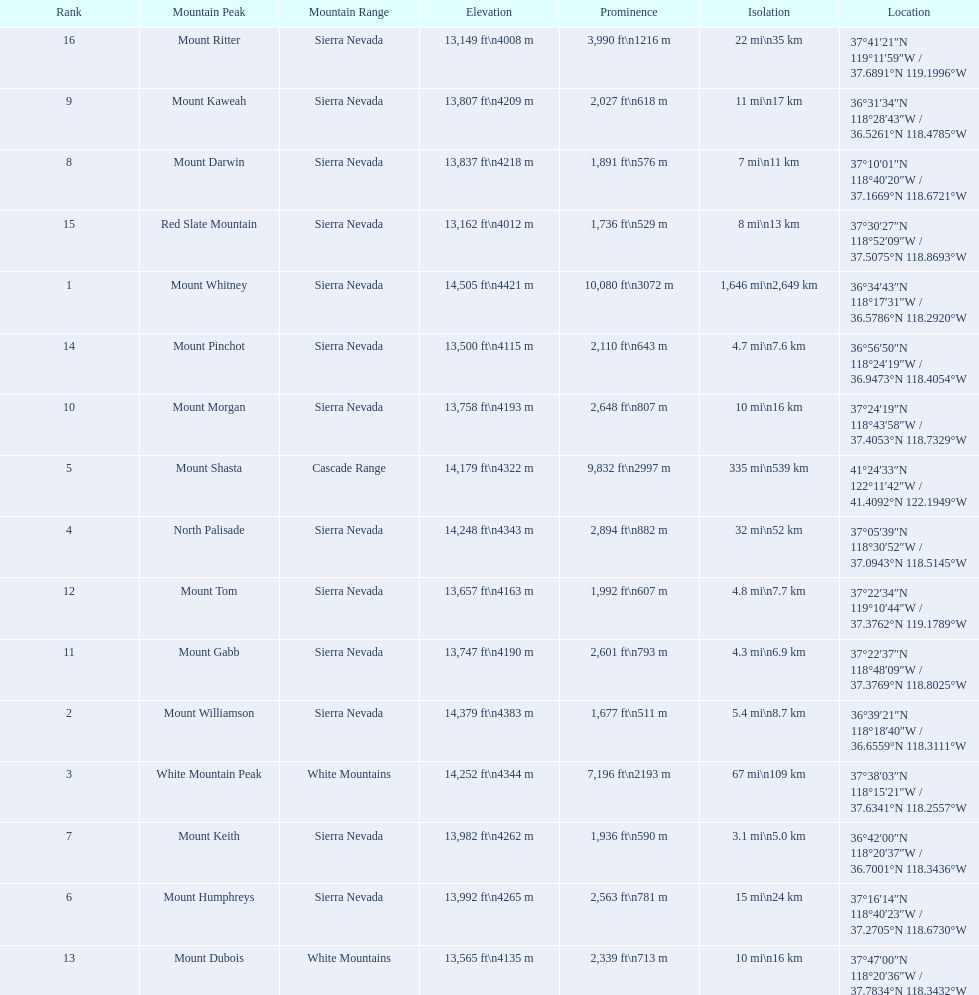Parse the full table. {'header': ['Rank', 'Mountain Peak', 'Mountain Range', 'Elevation', 'Prominence', 'Isolation', 'Location'], 'rows': [['16', 'Mount Ritter', 'Sierra Nevada', '13,149\xa0ft\\n4008\xa0m', '3,990\xa0ft\\n1216\xa0m', '22\xa0mi\\n35\xa0km', '37°41′21″N 119°11′59″W\ufeff / \ufeff37.6891°N 119.1996°W'], ['9', 'Mount Kaweah', 'Sierra Nevada', '13,807\xa0ft\\n4209\xa0m', '2,027\xa0ft\\n618\xa0m', '11\xa0mi\\n17\xa0km', '36°31′34″N 118°28′43″W\ufeff / \ufeff36.5261°N 118.4785°W'], ['8', 'Mount Darwin', 'Sierra Nevada', '13,837\xa0ft\\n4218\xa0m', '1,891\xa0ft\\n576\xa0m', '7\xa0mi\\n11\xa0km', '37°10′01″N 118°40′20″W\ufeff / \ufeff37.1669°N 118.6721°W'], ['15', 'Red Slate Mountain', 'Sierra Nevada', '13,162\xa0ft\\n4012\xa0m', '1,736\xa0ft\\n529\xa0m', '8\xa0mi\\n13\xa0km', '37°30′27″N 118°52′09″W\ufeff / \ufeff37.5075°N 118.8693°W'], ['1', 'Mount Whitney', 'Sierra Nevada', '14,505\xa0ft\\n4421\xa0m', '10,080\xa0ft\\n3072\xa0m', '1,646\xa0mi\\n2,649\xa0km', '36°34′43″N 118°17′31″W\ufeff / \ufeff36.5786°N 118.2920°W'], ['14', 'Mount Pinchot', 'Sierra Nevada', '13,500\xa0ft\\n4115\xa0m', '2,110\xa0ft\\n643\xa0m', '4.7\xa0mi\\n7.6\xa0km', '36°56′50″N 118°24′19″W\ufeff / \ufeff36.9473°N 118.4054°W'], ['10', 'Mount Morgan', 'Sierra Nevada', '13,758\xa0ft\\n4193\xa0m', '2,648\xa0ft\\n807\xa0m', '10\xa0mi\\n16\xa0km', '37°24′19″N 118°43′58″W\ufeff / \ufeff37.4053°N 118.7329°W'], ['5', 'Mount Shasta', 'Cascade Range', '14,179\xa0ft\\n4322\xa0m', '9,832\xa0ft\\n2997\xa0m', '335\xa0mi\\n539\xa0km', '41°24′33″N 122°11′42″W\ufeff / \ufeff41.4092°N 122.1949°W'], ['4', 'North Palisade', 'Sierra Nevada', '14,248\xa0ft\\n4343\xa0m', '2,894\xa0ft\\n882\xa0m', '32\xa0mi\\n52\xa0km', '37°05′39″N 118°30′52″W\ufeff / \ufeff37.0943°N 118.5145°W'], ['12', 'Mount Tom', 'Sierra Nevada', '13,657\xa0ft\\n4163\xa0m', '1,992\xa0ft\\n607\xa0m', '4.8\xa0mi\\n7.7\xa0km', '37°22′34″N 119°10′44″W\ufeff / \ufeff37.3762°N 119.1789°W'], ['11', 'Mount Gabb', 'Sierra Nevada', '13,747\xa0ft\\n4190\xa0m', '2,601\xa0ft\\n793\xa0m', '4.3\xa0mi\\n6.9\xa0km', '37°22′37″N 118°48′09″W\ufeff / \ufeff37.3769°N 118.8025°W'], ['2', 'Mount Williamson', 'Sierra Nevada', '14,379\xa0ft\\n4383\xa0m', '1,677\xa0ft\\n511\xa0m', '5.4\xa0mi\\n8.7\xa0km', '36°39′21″N 118°18′40″W\ufeff / \ufeff36.6559°N 118.3111°W'], ['3', 'White Mountain Peak', 'White Mountains', '14,252\xa0ft\\n4344\xa0m', '7,196\xa0ft\\n2193\xa0m', '67\xa0mi\\n109\xa0km', '37°38′03″N 118°15′21″W\ufeff / \ufeff37.6341°N 118.2557°W'], ['7', 'Mount Keith', 'Sierra Nevada', '13,982\xa0ft\\n4262\xa0m', '1,936\xa0ft\\n590\xa0m', '3.1\xa0mi\\n5.0\xa0km', '36°42′00″N 118°20′37″W\ufeff / \ufeff36.7001°N 118.3436°W'], ['6', 'Mount Humphreys', 'Sierra Nevada', '13,992\xa0ft\\n4265\xa0m', '2,563\xa0ft\\n781\xa0m', '15\xa0mi\\n24\xa0km', '37°16′14″N 118°40′23″W\ufeff / \ufeff37.2705°N 118.6730°W'], ['13', 'Mount Dubois', 'White Mountains', '13,565\xa0ft\\n4135\xa0m', '2,339\xa0ft\\n713\xa0m', '10\xa0mi\\n16\xa0km', '37°47′00″N 118°20′36″W\ufeff / \ufeff37.7834°N 118.3432°W']]} What are the listed elevations? 14,505 ft\n4421 m, 14,379 ft\n4383 m, 14,252 ft\n4344 m, 14,248 ft\n4343 m, 14,179 ft\n4322 m, 13,992 ft\n4265 m, 13,982 ft\n4262 m, 13,837 ft\n4218 m, 13,807 ft\n4209 m, 13,758 ft\n4193 m, 13,747 ft\n4190 m, 13,657 ft\n4163 m, 13,565 ft\n4135 m, 13,500 ft\n4115 m, 13,162 ft\n4012 m, 13,149 ft\n4008 m. Which of those is 13,149 ft or below? 13,149 ft\n4008 m. To what mountain peak does that value correspond? Mount Ritter. 